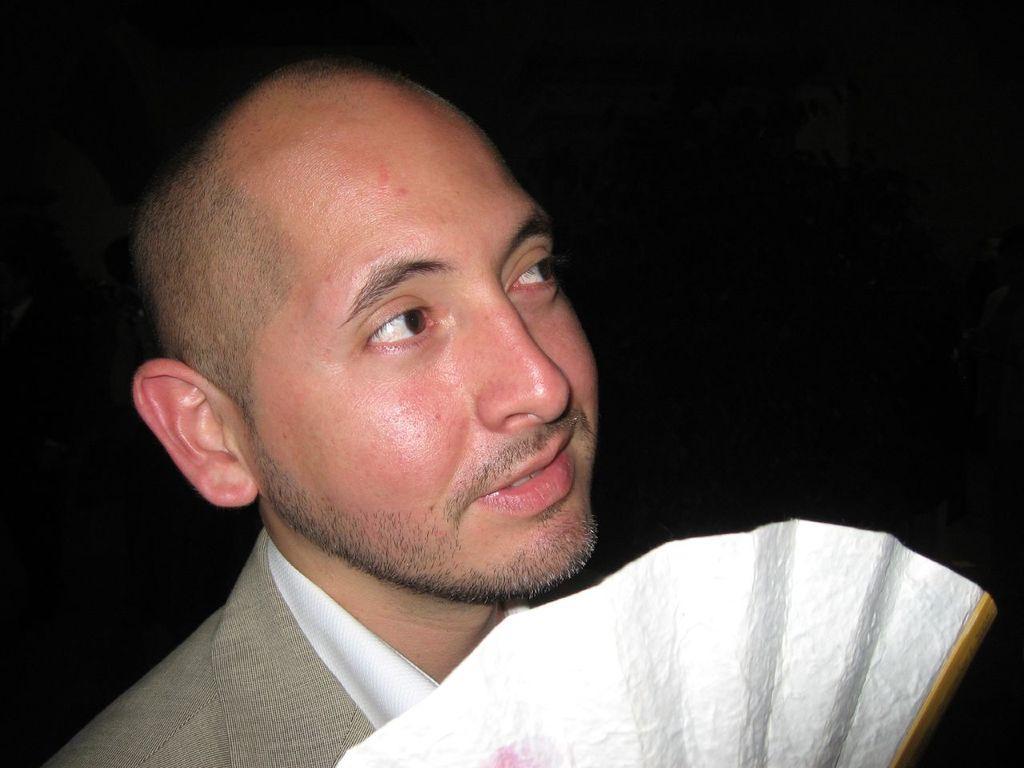In one or two sentences, can you explain what this image depicts? In this image there is a person with a smile on his face and he is holding something in his hand. The background is dark. 